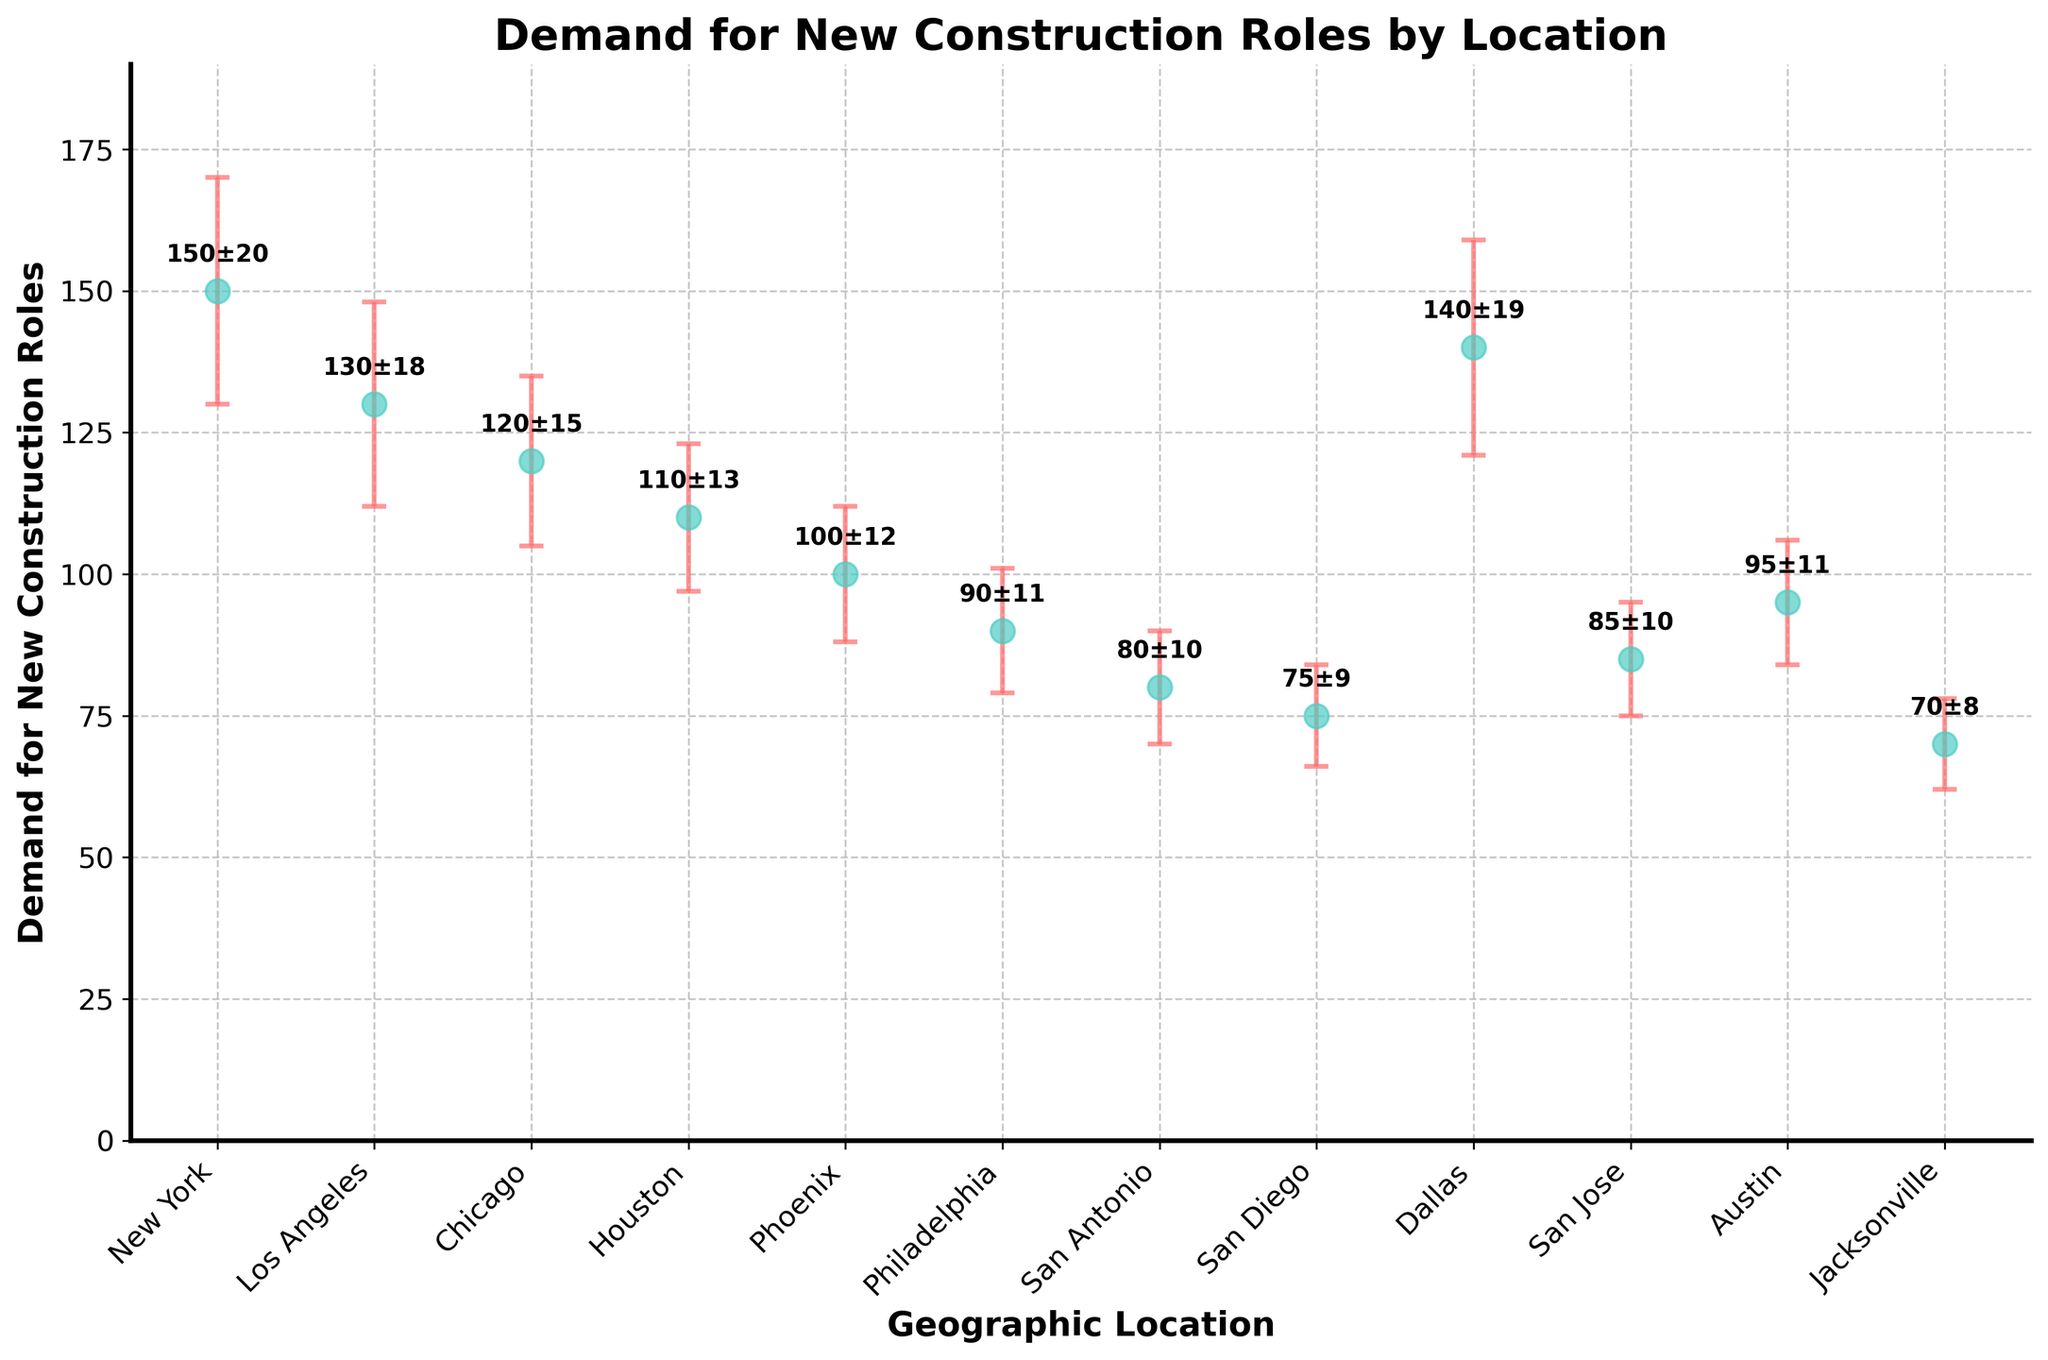What's the title of the plot? The title of the plot is tasked with summarizing the overall purpose of the visualization. In this case, the title reads "Demand for New Construction Roles by Location."
Answer: Demand for New Construction Roles by Location Which geographic location has the highest demand for new construction roles? By inspecting the y-axis values and the corresponding error bars, we can see that New York has the highest central demand value of 150.
Answer: New York What's the difference in demand between New York and Philadelphia? New York's demand is 150 and Philadelphia's demand is 90. The difference is calculated as 150 - 90.
Answer: 60 How many locations have a demand greater than 100? By examining the y-axis values, the locations with a demand greater than 100 are New York (150), Los Angeles (130), Chicago (120), Houston (110), Dallas (140). Counting these gives us five locations.
Answer: 5 What is the approximate range of standard deviations across all geographic locations? The standard deviation values range from the lowest of 8 (Jacksonville) to the highest of 20 (New York).
Answer: 8 to 20 Which two locations have similar levels of demand for new construction roles? By comparing the values closely, San Jose with a demand of 85 and Philadelphia with a demand of 90 appear to be the most similar, each falling within a short range of each other.
Answer: San Jose and Philadelphia What's the combined demand for new construction roles in Los Angeles and Chicago? Los Angeles has a demand of 130, and Chicago has a demand of 120. Summing these together results in 130 + 120.
Answer: 250 Which location has the smallest standard deviation and what is the value? By looking at the error bars, Jacksonville has the smallest standard deviation value of 8.
Answer: Jacksonville, 8 What's the total number of geographic locations represented in the plot? Counting the number of unique data points on the x-axis, these are all the explicit locations included in the dataset. The total in this case is 12.
Answer: 12 Has any geographic location an error bar that causes the demand to overlap with Dallas's demand? Dallas has a demand of 140, and its error bar ranges ±19 to give a range from 121 to 159. Chicago with a demand value of 120 and an error bar of ±15 ranges from 105 to 135, which does overlap with Dallas's lower bound (121).
Answer: Yes, Chicago 